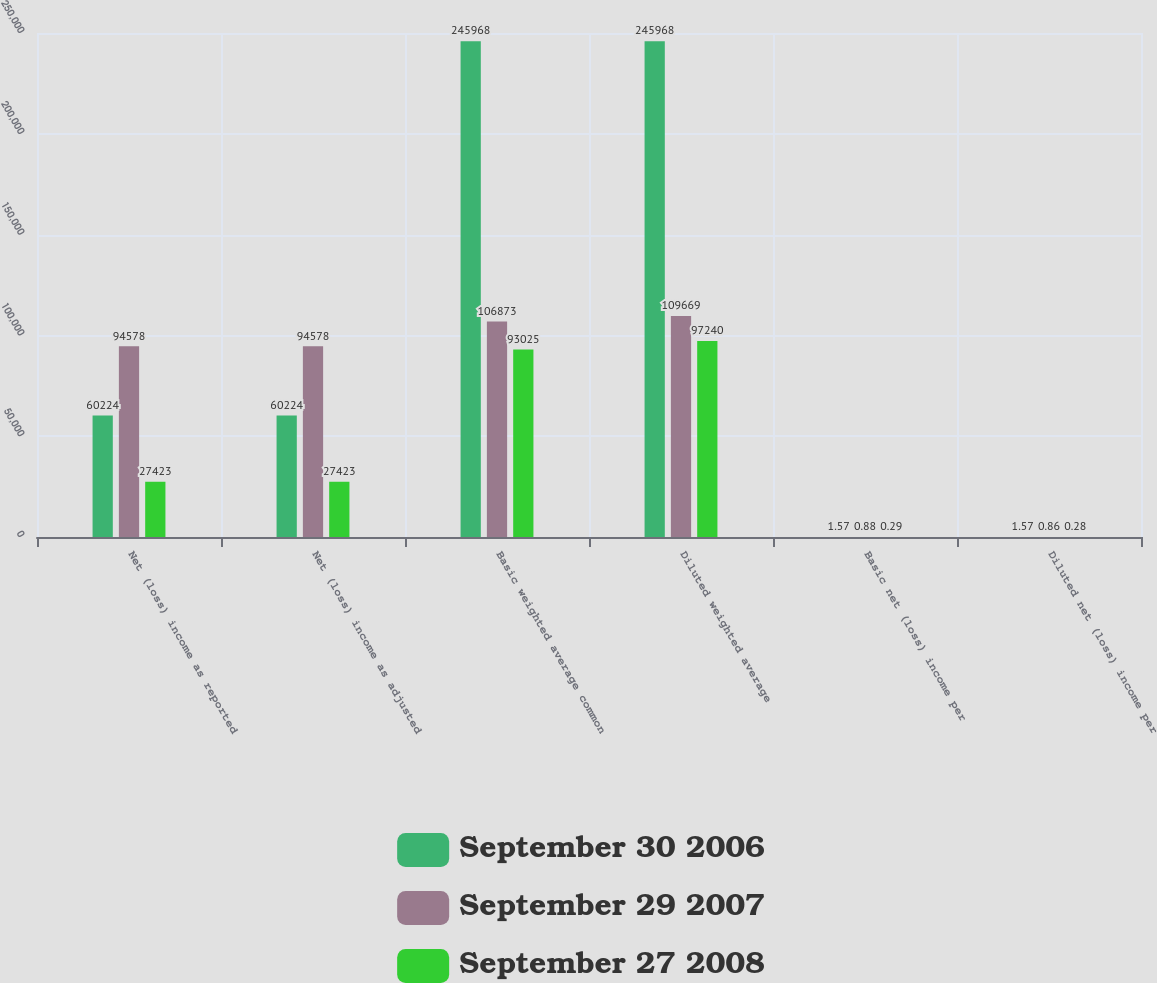<chart> <loc_0><loc_0><loc_500><loc_500><stacked_bar_chart><ecel><fcel>Net (loss) income as reported<fcel>Net (loss) income as adjusted<fcel>Basic weighted average common<fcel>Diluted weighted average<fcel>Basic net (loss) income per<fcel>Diluted net (loss) income per<nl><fcel>September 30 2006<fcel>60224<fcel>60224<fcel>245968<fcel>245968<fcel>1.57<fcel>1.57<nl><fcel>September 29 2007<fcel>94578<fcel>94578<fcel>106873<fcel>109669<fcel>0.88<fcel>0.86<nl><fcel>September 27 2008<fcel>27423<fcel>27423<fcel>93025<fcel>97240<fcel>0.29<fcel>0.28<nl></chart> 